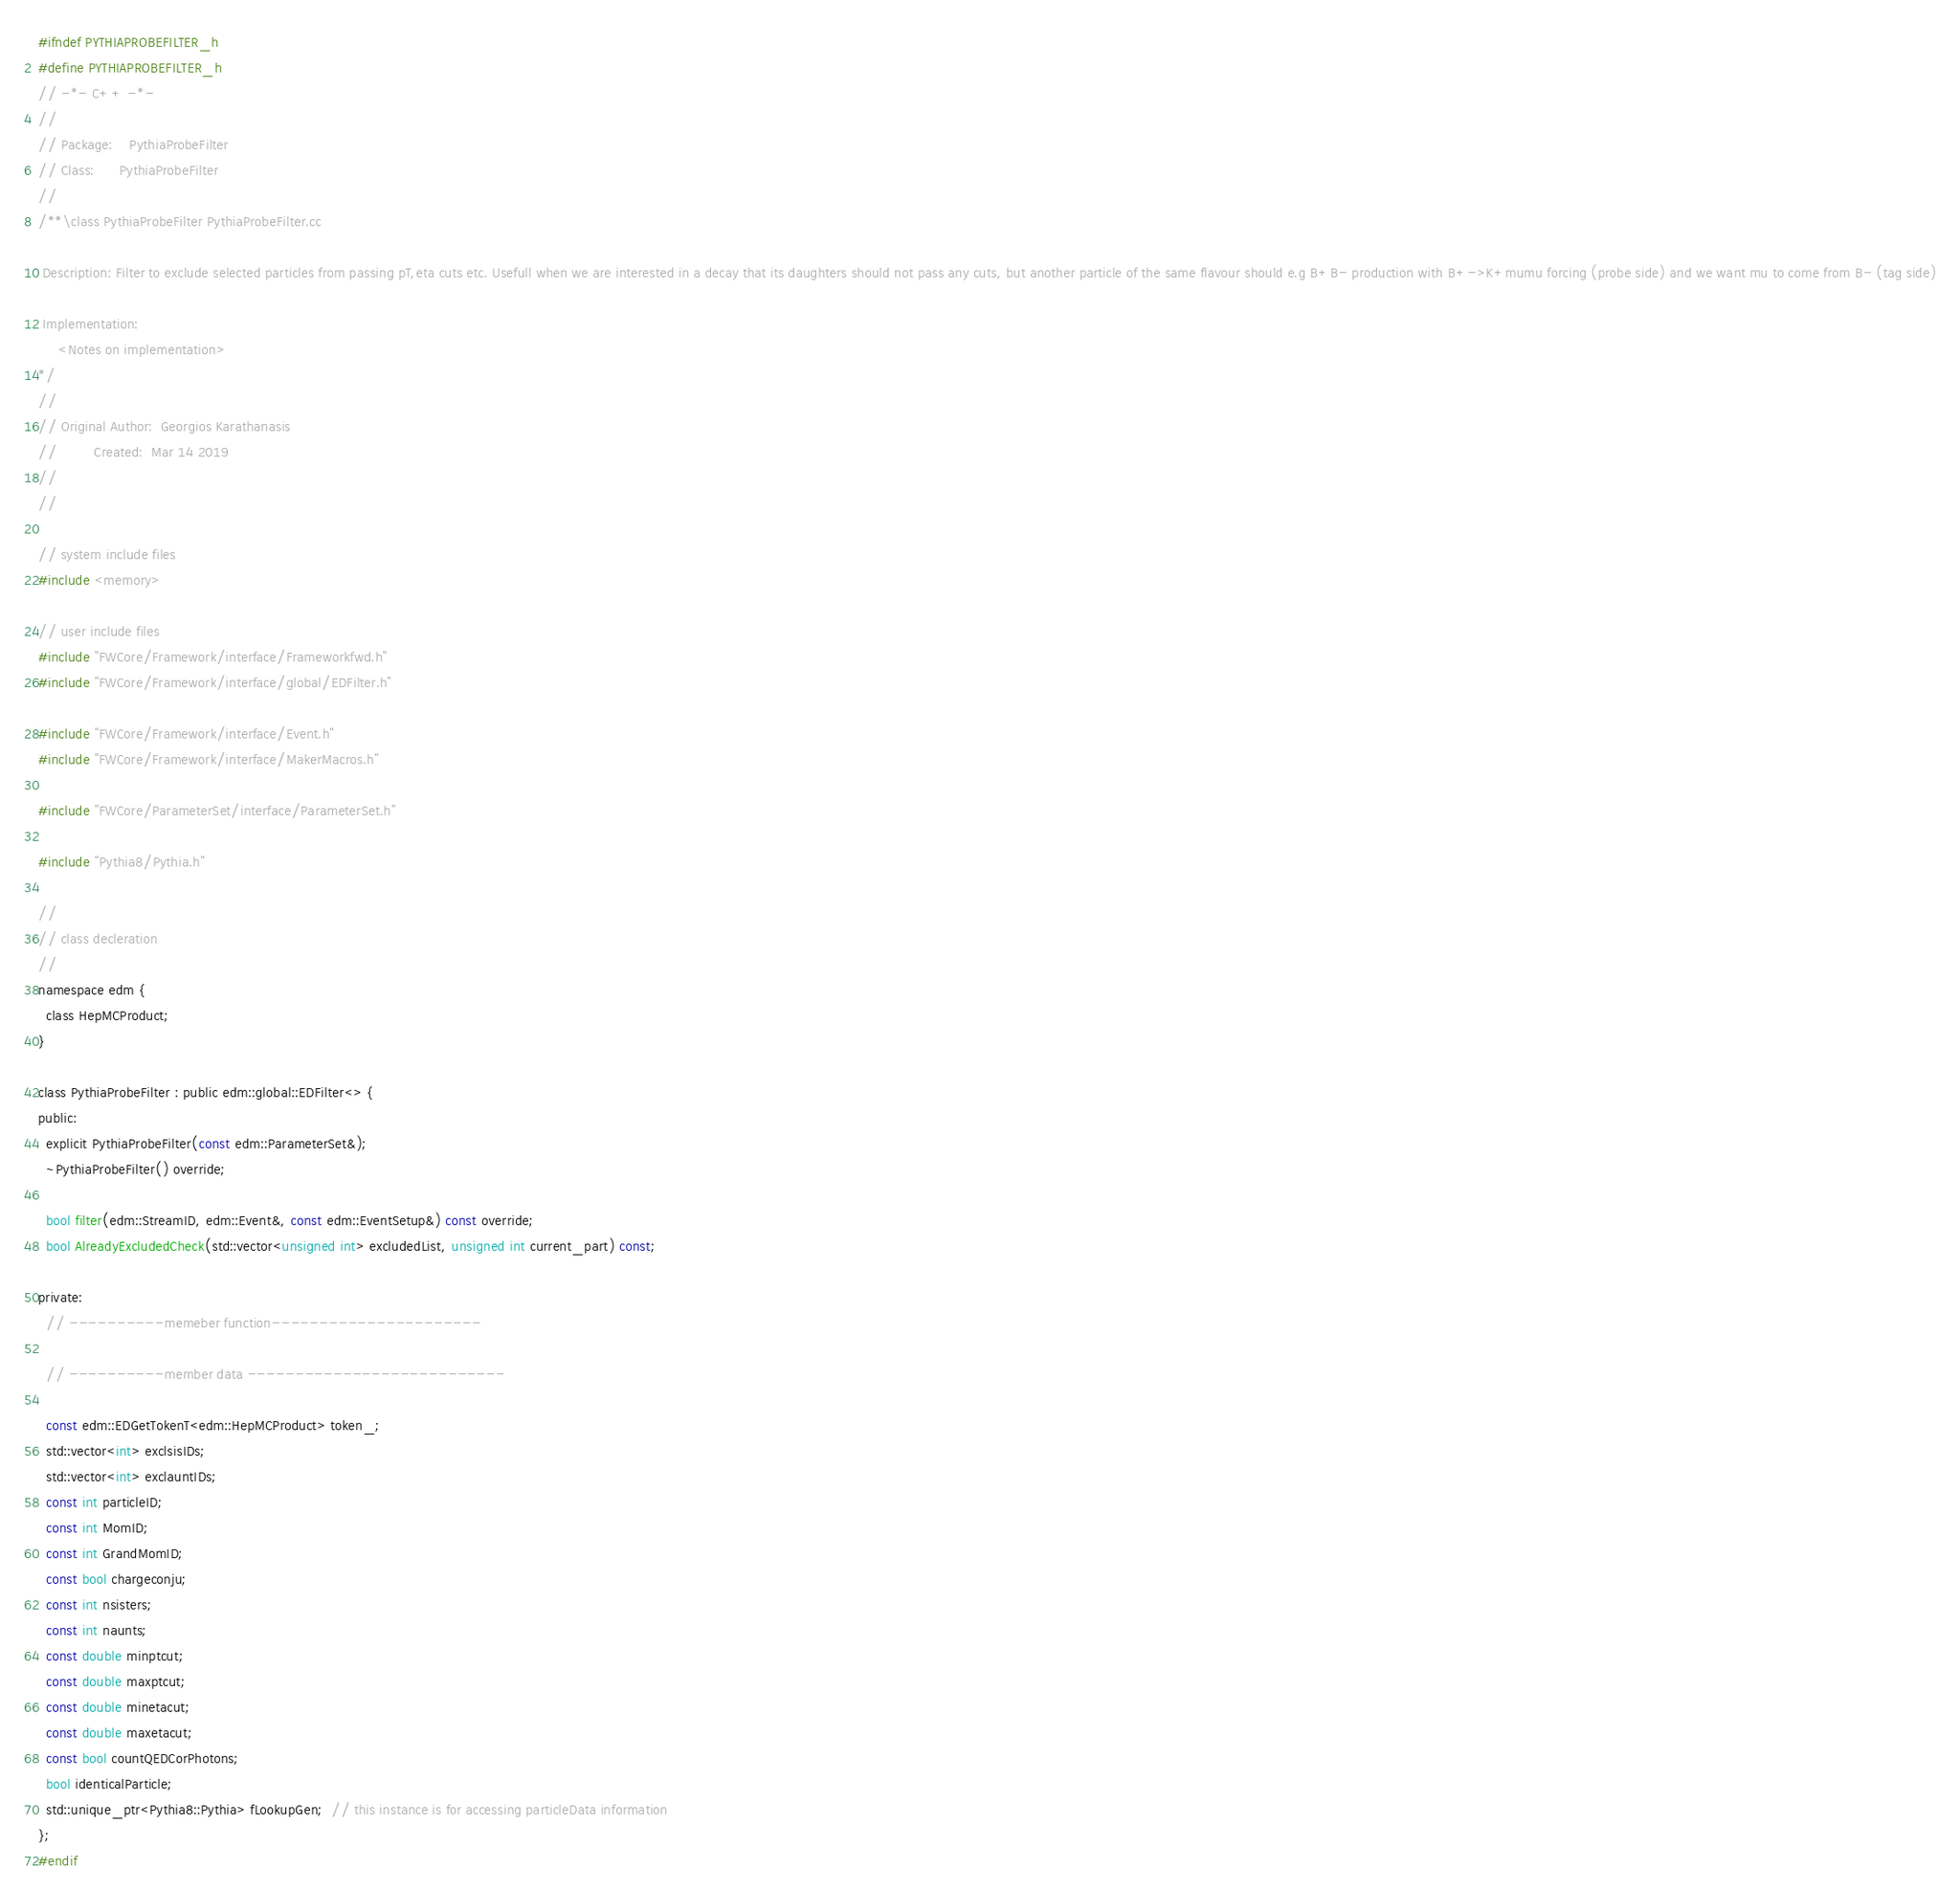<code> <loc_0><loc_0><loc_500><loc_500><_C_>#ifndef PYTHIAPROBEFILTER_h
#define PYTHIAPROBEFILTER_h
// -*- C++ -*-
//
// Package:    PythiaProbeFilter
// Class:      PythiaProbeFilter
//
/**\class PythiaProbeFilter PythiaProbeFilter.cc 

 Description: Filter to exclude selected particles from passing pT,eta cuts etc. Usefull when we are interested in a decay that its daughters should not pass any cuts, but another particle of the same flavour should e.g B+B- production with B+->K+mumu forcing (probe side) and we want mu to come from B- (tag side)

 Implementation:
     <Notes on implementation>
*/
//
// Original Author:  Georgios Karathanasis
//         Created:  Mar 14 2019
//
//

// system include files
#include <memory>

// user include files
#include "FWCore/Framework/interface/Frameworkfwd.h"
#include "FWCore/Framework/interface/global/EDFilter.h"

#include "FWCore/Framework/interface/Event.h"
#include "FWCore/Framework/interface/MakerMacros.h"

#include "FWCore/ParameterSet/interface/ParameterSet.h"

#include "Pythia8/Pythia.h"

//
// class decleration
//
namespace edm {
  class HepMCProduct;
}

class PythiaProbeFilter : public edm::global::EDFilter<> {
public:
  explicit PythiaProbeFilter(const edm::ParameterSet&);
  ~PythiaProbeFilter() override;

  bool filter(edm::StreamID, edm::Event&, const edm::EventSetup&) const override;
  bool AlreadyExcludedCheck(std::vector<unsigned int> excludedList, unsigned int current_part) const;

private:
  // ----------memeber function----------------------

  // ----------member data ---------------------------

  const edm::EDGetTokenT<edm::HepMCProduct> token_;
  std::vector<int> exclsisIDs;
  std::vector<int> exclauntIDs;
  const int particleID;
  const int MomID;
  const int GrandMomID;
  const bool chargeconju;
  const int nsisters;
  const int naunts;
  const double minptcut;
  const double maxptcut;
  const double minetacut;
  const double maxetacut;
  const bool countQEDCorPhotons;
  bool identicalParticle;
  std::unique_ptr<Pythia8::Pythia> fLookupGen;  // this instance is for accessing particleData information
};
#endif
</code> 